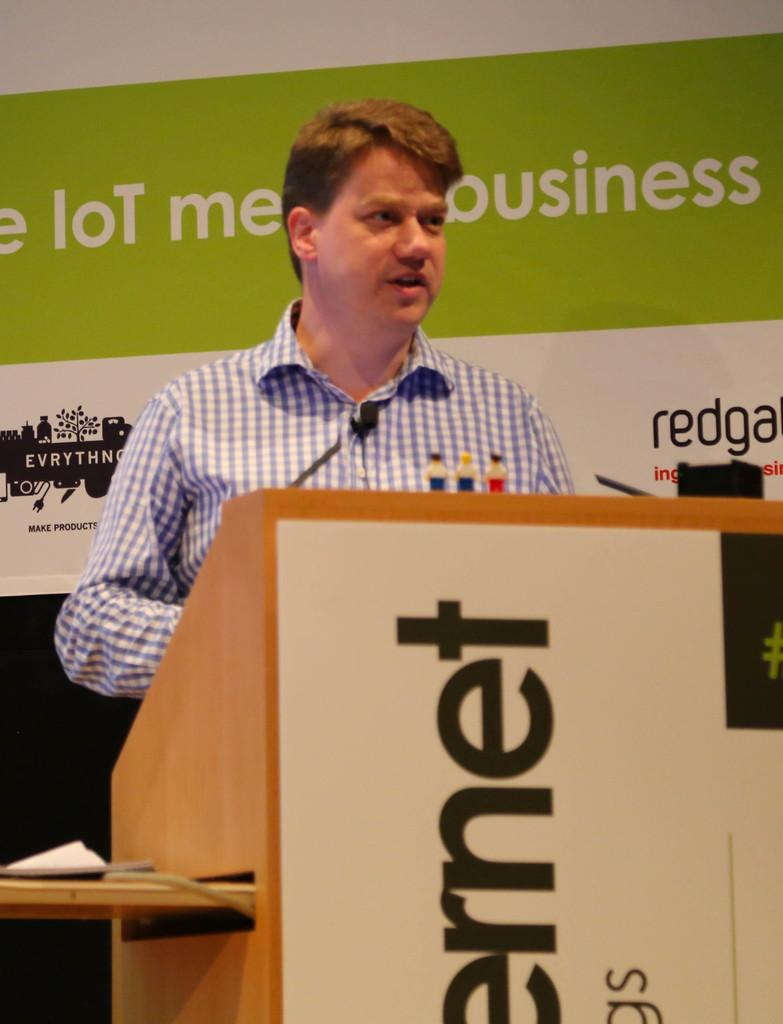<image>
Provide a brief description of the given image. A man at a podium with the word business behind his head. 